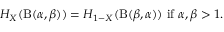<formula> <loc_0><loc_0><loc_500><loc_500>H _ { X } ( B ( \alpha , \beta ) ) = H _ { 1 - X } ( B ( \beta , \alpha ) ) { i f } \alpha , \beta > 1 .</formula> 